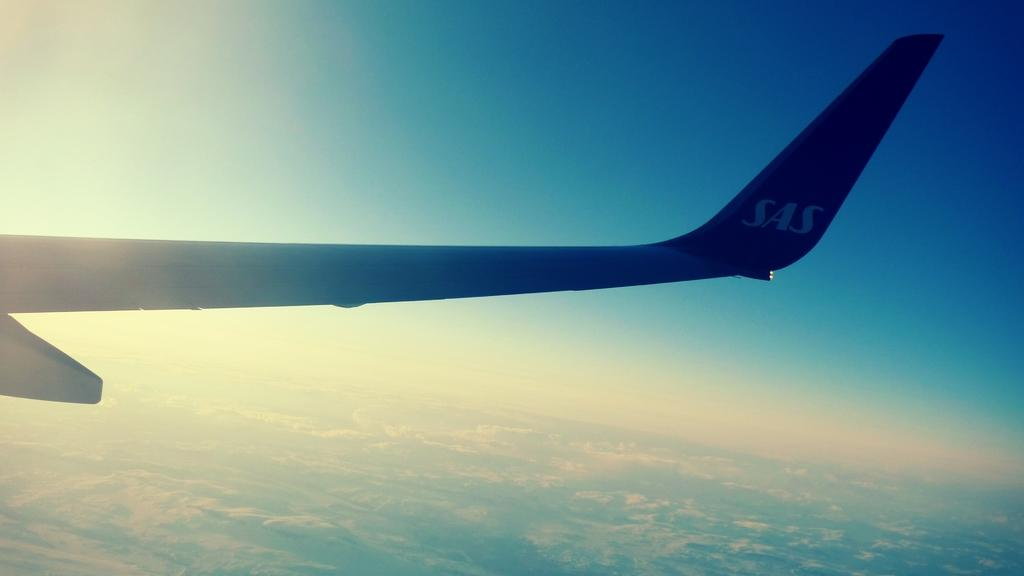<image>
Relay a brief, clear account of the picture shown. A wingtip of SAS passenger jet is shown against the brightly lit sky. 